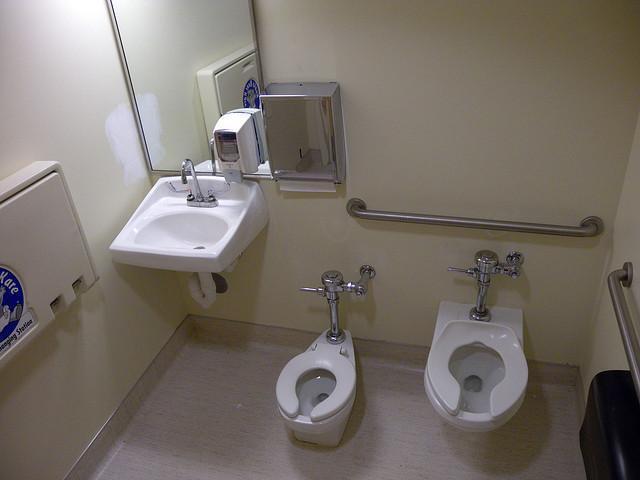How many items appear to be made of porcelain?
Select the accurate answer and provide justification: `Answer: choice
Rationale: srationale.`
Options: Six, eight, three, five. Answer: three.
Rationale: The sink and two toilets are made of porcelain. 